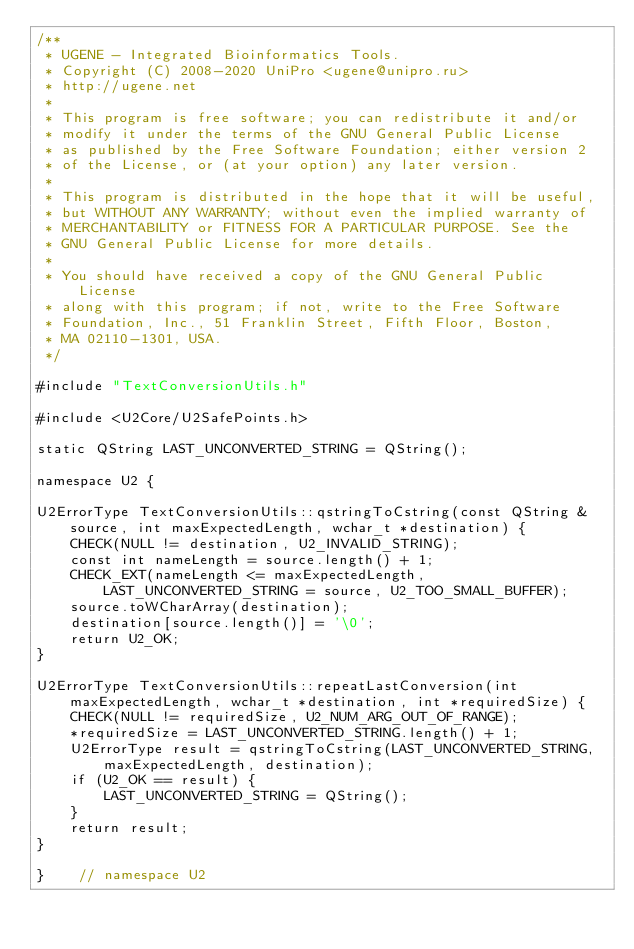<code> <loc_0><loc_0><loc_500><loc_500><_C++_>/**
 * UGENE - Integrated Bioinformatics Tools.
 * Copyright (C) 2008-2020 UniPro <ugene@unipro.ru>
 * http://ugene.net
 *
 * This program is free software; you can redistribute it and/or
 * modify it under the terms of the GNU General Public License
 * as published by the Free Software Foundation; either version 2
 * of the License, or (at your option) any later version.
 *
 * This program is distributed in the hope that it will be useful,
 * but WITHOUT ANY WARRANTY; without even the implied warranty of
 * MERCHANTABILITY or FITNESS FOR A PARTICULAR PURPOSE. See the
 * GNU General Public License for more details.
 *
 * You should have received a copy of the GNU General Public License
 * along with this program; if not, write to the Free Software
 * Foundation, Inc., 51 Franklin Street, Fifth Floor, Boston,
 * MA 02110-1301, USA.
 */

#include "TextConversionUtils.h"

#include <U2Core/U2SafePoints.h>

static QString LAST_UNCONVERTED_STRING = QString();

namespace U2 {

U2ErrorType TextConversionUtils::qstringToCstring(const QString &source, int maxExpectedLength, wchar_t *destination) {
    CHECK(NULL != destination, U2_INVALID_STRING);
    const int nameLength = source.length() + 1;
    CHECK_EXT(nameLength <= maxExpectedLength, LAST_UNCONVERTED_STRING = source, U2_TOO_SMALL_BUFFER);
    source.toWCharArray(destination);
    destination[source.length()] = '\0';
    return U2_OK;
}

U2ErrorType TextConversionUtils::repeatLastConversion(int maxExpectedLength, wchar_t *destination, int *requiredSize) {
    CHECK(NULL != requiredSize, U2_NUM_ARG_OUT_OF_RANGE);
    *requiredSize = LAST_UNCONVERTED_STRING.length() + 1;
    U2ErrorType result = qstringToCstring(LAST_UNCONVERTED_STRING, maxExpectedLength, destination);
    if (U2_OK == result) {
        LAST_UNCONVERTED_STRING = QString();
    }
    return result;
}

}    // namespace U2
</code> 